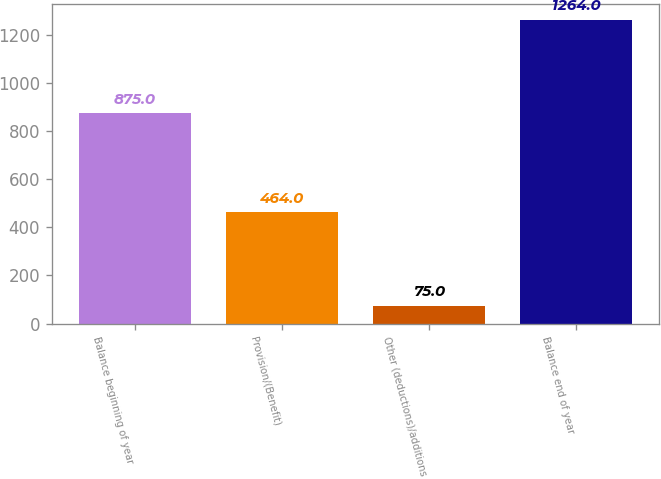Convert chart. <chart><loc_0><loc_0><loc_500><loc_500><bar_chart><fcel>Balance beginning of year<fcel>Provision/(Benefit)<fcel>Other (deductions)/additions<fcel>Balance end of year<nl><fcel>875<fcel>464<fcel>75<fcel>1264<nl></chart> 